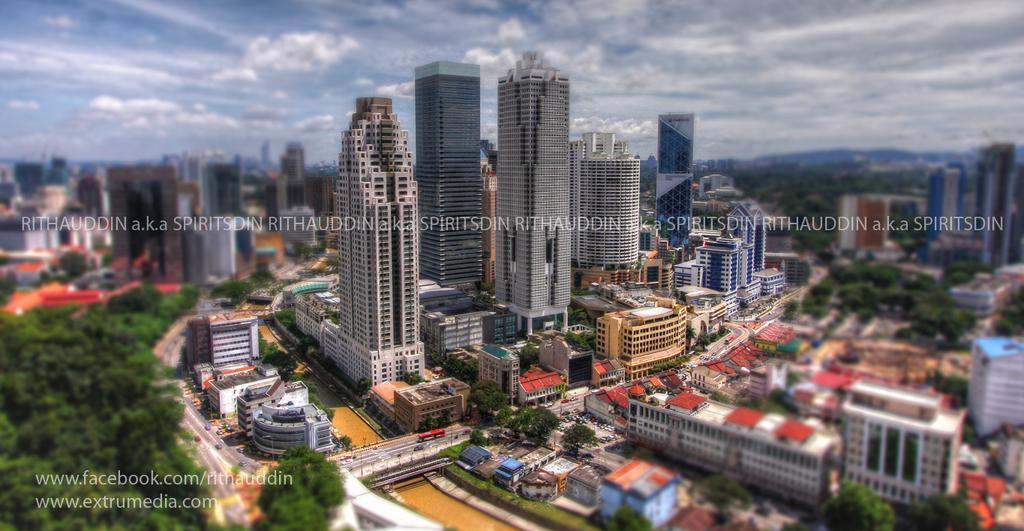In one or two sentences, can you explain what this image depicts? In this picture we can see vehicles on the road, here we can see buildings, trees and some objects and in the background we can see mountains and sky with clouds, here we can see some text on it. 